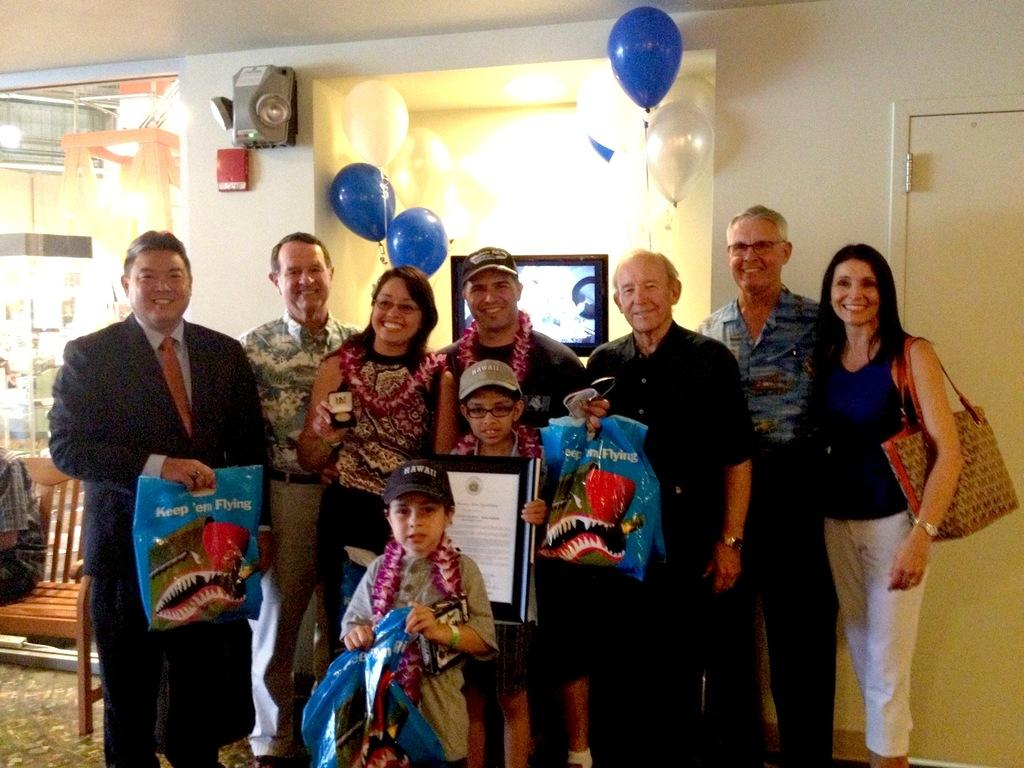What is happening in the image? There is a group of people in the image, and they are standing and carrying objects. Can you describe the person at the center right side of the image? There is a person sitting on an object at the center right side of the image. What type of tramp can be seen in the image? There is no tramp present in the image. How many stalks of celery are being carried by the people in the image? The image does not specify the type of objects being carried by the people, so it is impossible to determine if any of them are celery stalks. 